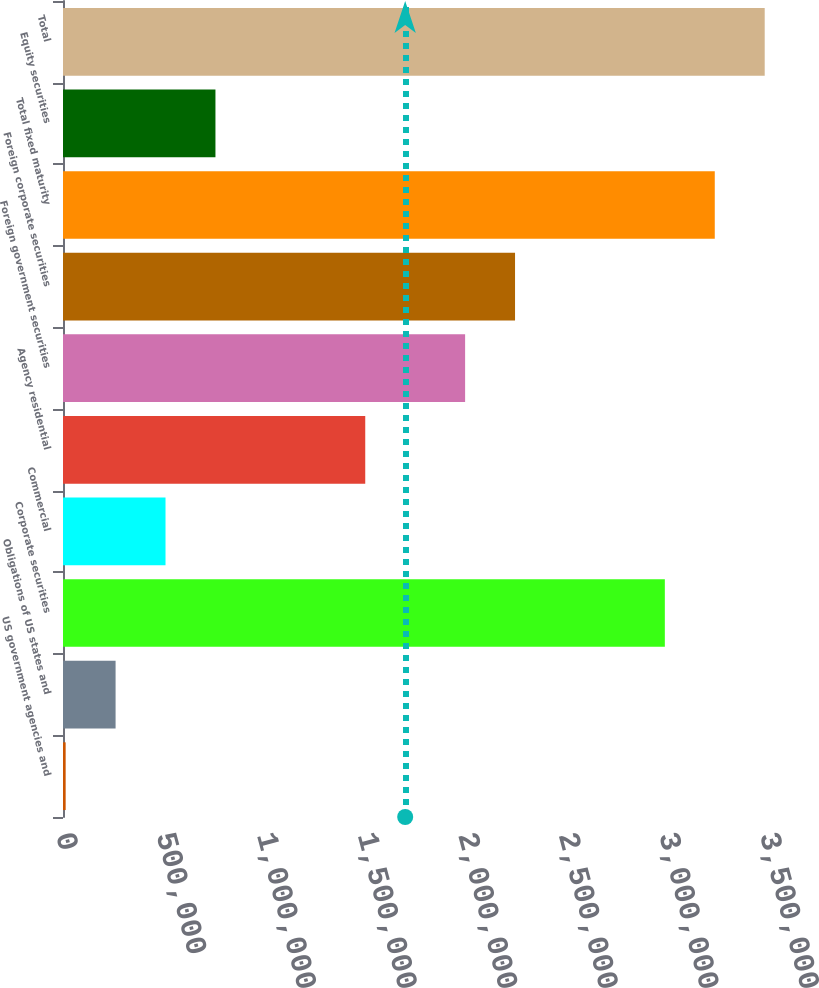<chart> <loc_0><loc_0><loc_500><loc_500><bar_chart><fcel>US government agencies and<fcel>Obligations of US states and<fcel>Corporate securities<fcel>Commercial<fcel>Agency residential<fcel>Foreign government securities<fcel>Foreign corporate securities<fcel>Total fixed maturity<fcel>Equity securities<fcel>Total<nl><fcel>13187<fcel>261429<fcel>2.9921e+06<fcel>509672<fcel>1.50264e+06<fcel>1.99913e+06<fcel>2.24737e+06<fcel>3.24034e+06<fcel>757914<fcel>3.48858e+06<nl></chart> 